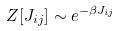<formula> <loc_0><loc_0><loc_500><loc_500>Z [ J _ { i j } ] \sim e ^ { - \beta J _ { i j } }</formula> 